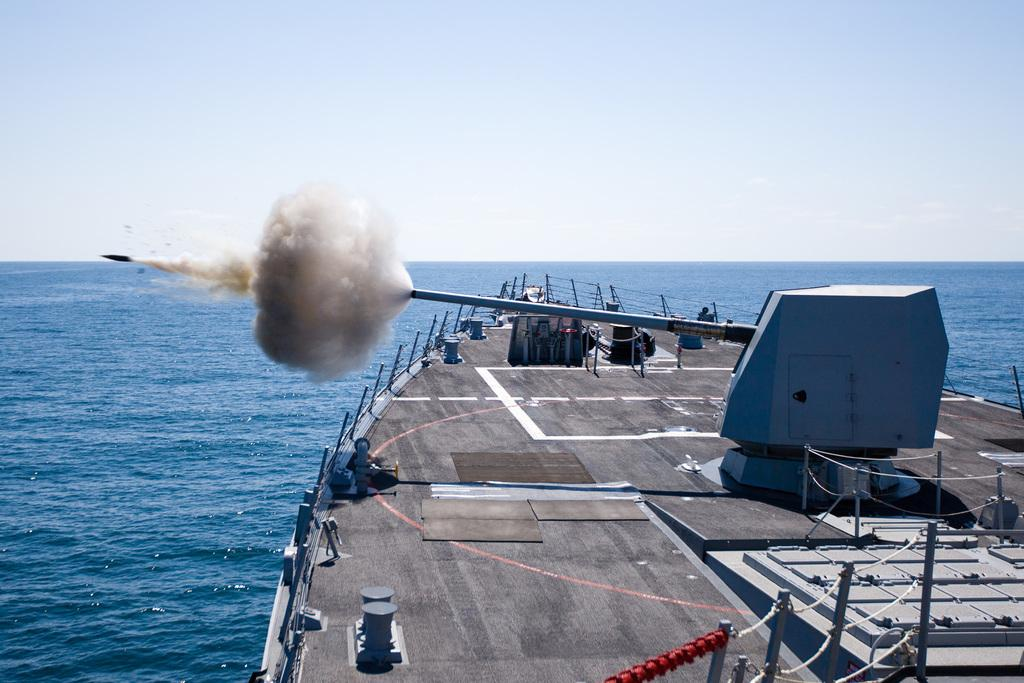What type of vehicle is on the surface of the water in the image? There is a ship on the surface of the water in the image. Where is the ship located in relation to the image? The ship is visible at the bottom of the image. What can be seen in the background of the image? There is a sky visible in the background of the image. What type of record is being played on the ship in the image? There is no record or music player visible in the image, so it cannot be determined if a record is being played. 